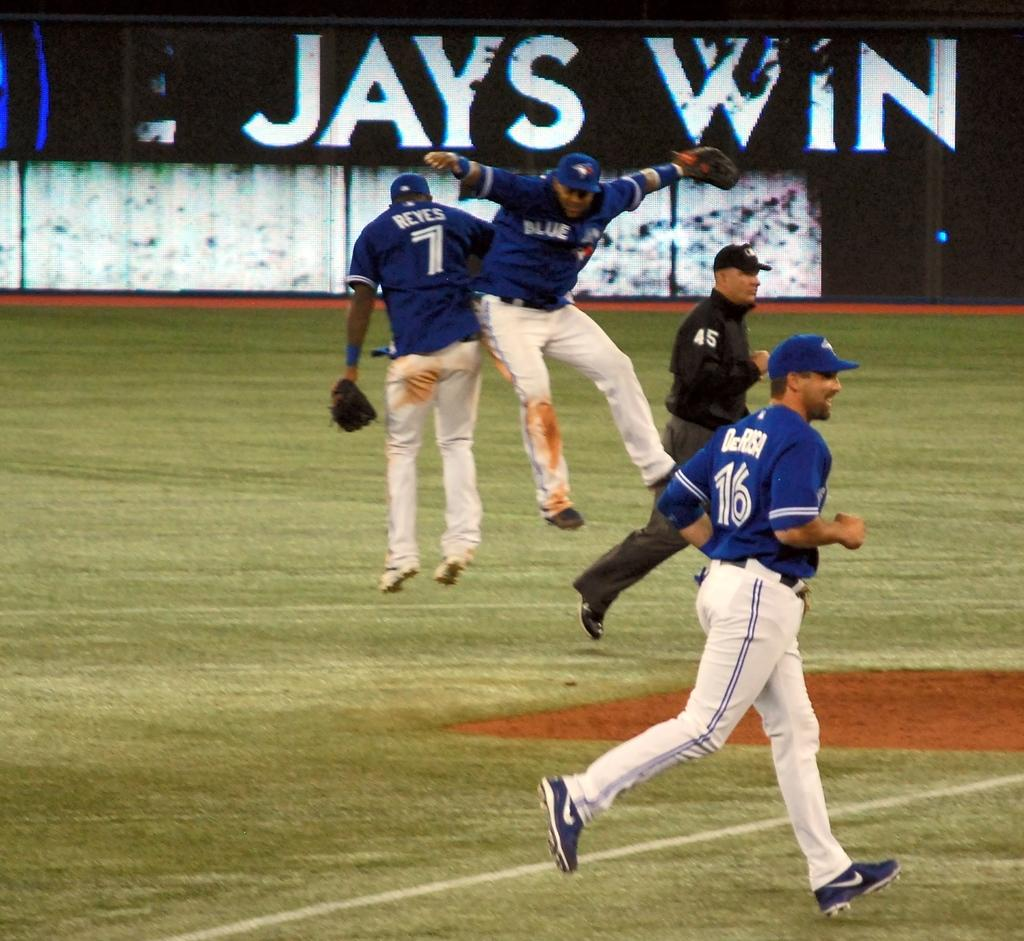<image>
Give a short and clear explanation of the subsequent image. Blue Jays team members showing excitement on the field with a sign behind them in the background that says JAYS WIN. 